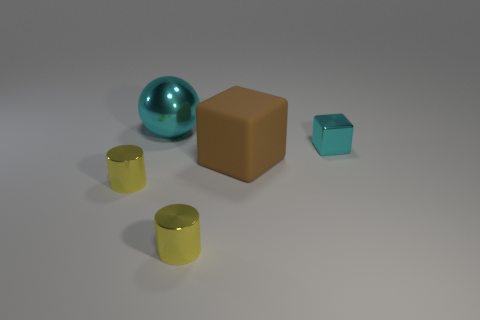Is there any other thing that is made of the same material as the big cube?
Offer a terse response. No. Are there any other things that have the same shape as the big metal object?
Offer a terse response. No. How many other large brown matte objects are the same shape as the brown thing?
Provide a short and direct response. 0. What material is the sphere that is the same color as the tiny shiny block?
Offer a terse response. Metal. There is a cube right of the big brown block; does it have the same size as the yellow cylinder on the right side of the cyan metal sphere?
Keep it short and to the point. Yes. What is the shape of the big object in front of the large cyan metallic ball?
Keep it short and to the point. Cube. What material is the other thing that is the same shape as the big brown rubber object?
Keep it short and to the point. Metal. There is a object right of the brown block; is it the same size as the ball?
Provide a succinct answer. No. What number of tiny cyan metallic blocks are in front of the tiny cyan shiny cube?
Provide a succinct answer. 0. Is the number of cylinders that are on the right side of the large brown object less than the number of big cyan metal objects that are in front of the metallic cube?
Offer a terse response. No. 